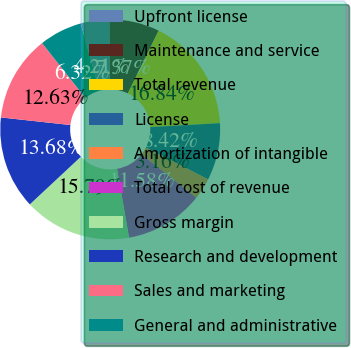<chart> <loc_0><loc_0><loc_500><loc_500><pie_chart><fcel>Upfront license<fcel>Maintenance and service<fcel>Total revenue<fcel>License<fcel>Amortization of intangible<fcel>Total cost of revenue<fcel>Gross margin<fcel>Research and development<fcel>Sales and marketing<fcel>General and administrative<nl><fcel>4.21%<fcel>7.37%<fcel>16.84%<fcel>8.42%<fcel>3.16%<fcel>11.58%<fcel>15.79%<fcel>13.68%<fcel>12.63%<fcel>6.32%<nl></chart> 